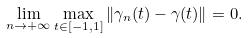Convert formula to latex. <formula><loc_0><loc_0><loc_500><loc_500>\lim _ { n \to + \infty } \max _ { t \in [ - 1 , 1 ] } \| \gamma _ { n } ( t ) - \gamma ( t ) \| = 0 .</formula> 